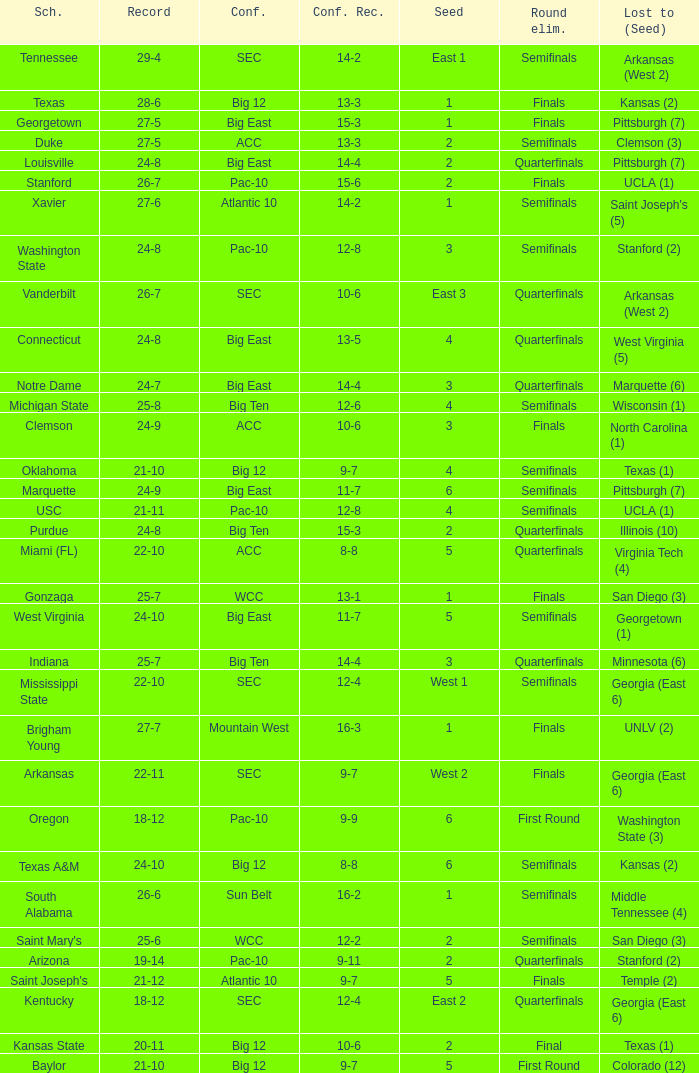What is the school with a conference record of 12-6? Michigan State. Help me parse the entirety of this table. {'header': ['Sch.', 'Record', 'Conf.', 'Conf. Rec.', 'Seed', 'Round elim.', 'Lost to (Seed)'], 'rows': [['Tennessee', '29-4', 'SEC', '14-2', 'East 1', 'Semifinals', 'Arkansas (West 2)'], ['Texas', '28-6', 'Big 12', '13-3', '1', 'Finals', 'Kansas (2)'], ['Georgetown', '27-5', 'Big East', '15-3', '1', 'Finals', 'Pittsburgh (7)'], ['Duke', '27-5', 'ACC', '13-3', '2', 'Semifinals', 'Clemson (3)'], ['Louisville', '24-8', 'Big East', '14-4', '2', 'Quarterfinals', 'Pittsburgh (7)'], ['Stanford', '26-7', 'Pac-10', '15-6', '2', 'Finals', 'UCLA (1)'], ['Xavier', '27-6', 'Atlantic 10', '14-2', '1', 'Semifinals', "Saint Joseph's (5)"], ['Washington State', '24-8', 'Pac-10', '12-8', '3', 'Semifinals', 'Stanford (2)'], ['Vanderbilt', '26-7', 'SEC', '10-6', 'East 3', 'Quarterfinals', 'Arkansas (West 2)'], ['Connecticut', '24-8', 'Big East', '13-5', '4', 'Quarterfinals', 'West Virginia (5)'], ['Notre Dame', '24-7', 'Big East', '14-4', '3', 'Quarterfinals', 'Marquette (6)'], ['Michigan State', '25-8', 'Big Ten', '12-6', '4', 'Semifinals', 'Wisconsin (1)'], ['Clemson', '24-9', 'ACC', '10-6', '3', 'Finals', 'North Carolina (1)'], ['Oklahoma', '21-10', 'Big 12', '9-7', '4', 'Semifinals', 'Texas (1)'], ['Marquette', '24-9', 'Big East', '11-7', '6', 'Semifinals', 'Pittsburgh (7)'], ['USC', '21-11', 'Pac-10', '12-8', '4', 'Semifinals', 'UCLA (1)'], ['Purdue', '24-8', 'Big Ten', '15-3', '2', 'Quarterfinals', 'Illinois (10)'], ['Miami (FL)', '22-10', 'ACC', '8-8', '5', 'Quarterfinals', 'Virginia Tech (4)'], ['Gonzaga', '25-7', 'WCC', '13-1', '1', 'Finals', 'San Diego (3)'], ['West Virginia', '24-10', 'Big East', '11-7', '5', 'Semifinals', 'Georgetown (1)'], ['Indiana', '25-7', 'Big Ten', '14-4', '3', 'Quarterfinals', 'Minnesota (6)'], ['Mississippi State', '22-10', 'SEC', '12-4', 'West 1', 'Semifinals', 'Georgia (East 6)'], ['Brigham Young', '27-7', 'Mountain West', '16-3', '1', 'Finals', 'UNLV (2)'], ['Arkansas', '22-11', 'SEC', '9-7', 'West 2', 'Finals', 'Georgia (East 6)'], ['Oregon', '18-12', 'Pac-10', '9-9', '6', 'First Round', 'Washington State (3)'], ['Texas A&M', '24-10', 'Big 12', '8-8', '6', 'Semifinals', 'Kansas (2)'], ['South Alabama', '26-6', 'Sun Belt', '16-2', '1', 'Semifinals', 'Middle Tennessee (4)'], ["Saint Mary's", '25-6', 'WCC', '12-2', '2', 'Semifinals', 'San Diego (3)'], ['Arizona', '19-14', 'Pac-10', '9-11', '2', 'Quarterfinals', 'Stanford (2)'], ["Saint Joseph's", '21-12', 'Atlantic 10', '9-7', '5', 'Finals', 'Temple (2)'], ['Kentucky', '18-12', 'SEC', '12-4', 'East 2', 'Quarterfinals', 'Georgia (East 6)'], ['Kansas State', '20-11', 'Big 12', '10-6', '2', 'Final', 'Texas (1)'], ['Baylor', '21-10', 'Big 12', '9-7', '5', 'First Round', 'Colorado (12)']]} 